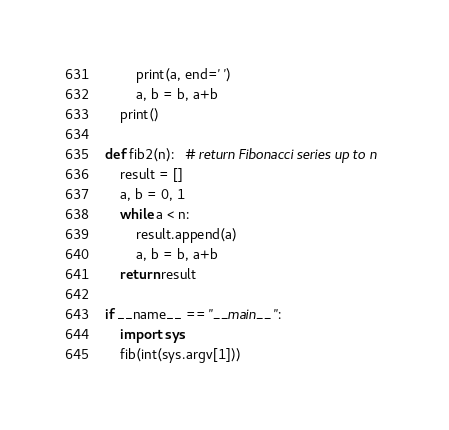Convert code to text. <code><loc_0><loc_0><loc_500><loc_500><_Python_>        print(a, end=' ')
        a, b = b, a+b
    print()

def fib2(n):   # return Fibonacci series up to n
    result = []
    a, b = 0, 1
    while a < n:
        result.append(a)
        a, b = b, a+b
    return result

if __name__ == "__main__":
    import sys
    fib(int(sys.argv[1]))




</code> 